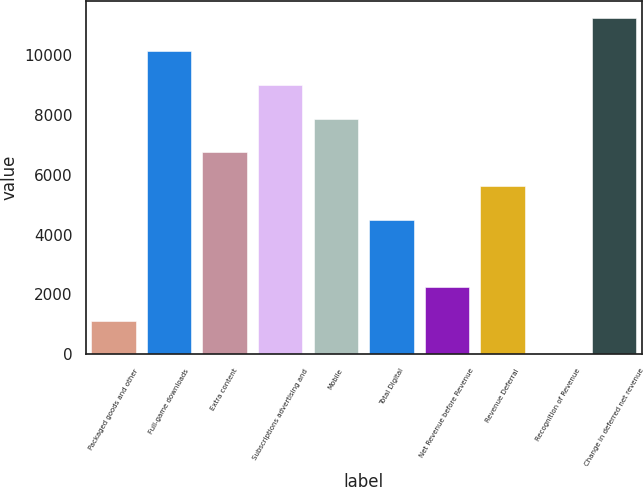Convert chart to OTSL. <chart><loc_0><loc_0><loc_500><loc_500><bar_chart><fcel>Packaged goods and other<fcel>Full-game downloads<fcel>Extra content<fcel>Subscriptions advertising and<fcel>Mobile<fcel>Total Digital<fcel>Net Revenue before Revenue<fcel>Revenue Deferral<fcel>Recognition of Revenue<fcel>Change in deferred net revenue<nl><fcel>1128.6<fcel>10125.4<fcel>6751.6<fcel>9000.8<fcel>7876.2<fcel>4502.4<fcel>2253.2<fcel>5627<fcel>4<fcel>11250<nl></chart> 